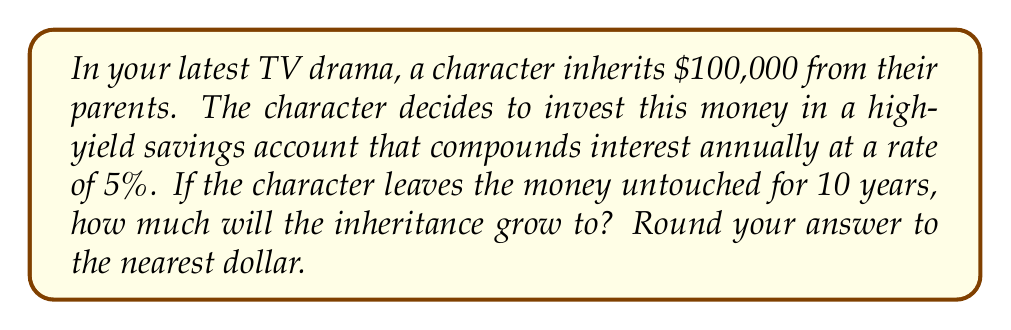Show me your answer to this math problem. To solve this problem, we'll use the compound interest formula:

$$A = P(1 + r)^n$$

Where:
$A$ = Final amount
$P$ = Principal (initial investment)
$r$ = Annual interest rate (in decimal form)
$n$ = Number of years

Given:
$P = 100,000$
$r = 0.05$ (5% converted to decimal)
$n = 10$ years

Let's plug these values into the formula:

$$A = 100,000(1 + 0.05)^{10}$$

Now, let's solve step-by-step:

1. Calculate $(1 + 0.05)^{10}$:
   $$(1.05)^{10} = 1.6288946...$$

2. Multiply the result by the principal:
   $$100,000 \times 1.6288946... = 162,889.46...$$

3. Round to the nearest dollar:
   $162,889

Therefore, after 10 years, the character's inheritance will grow to $162,889.
Answer: $162,889 